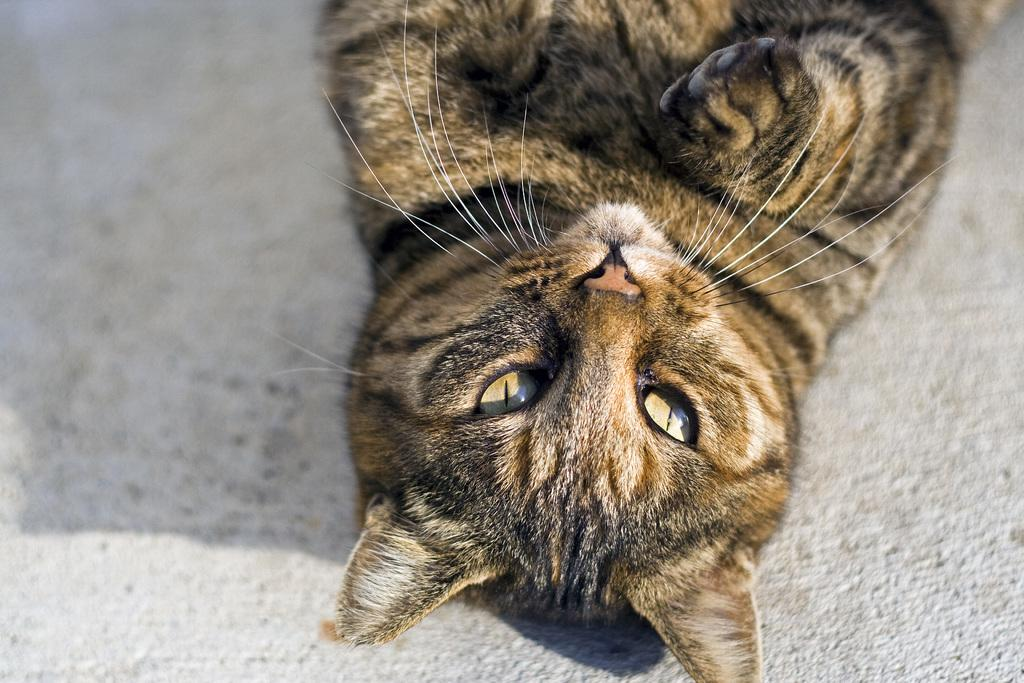What type of animal is present in the image? There is a cat in the image. What is the cat doing in the image? The cat is lying on the floor. What type of humor can be seen in the image? There is no humor present in the image; it simply shows a cat lying on the floor. What kind of toy is the cat playing with in the image? There is no toy present in the image; the cat is just lying on the floor. 